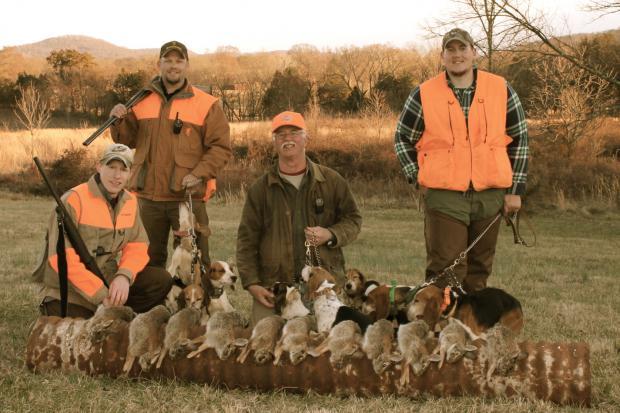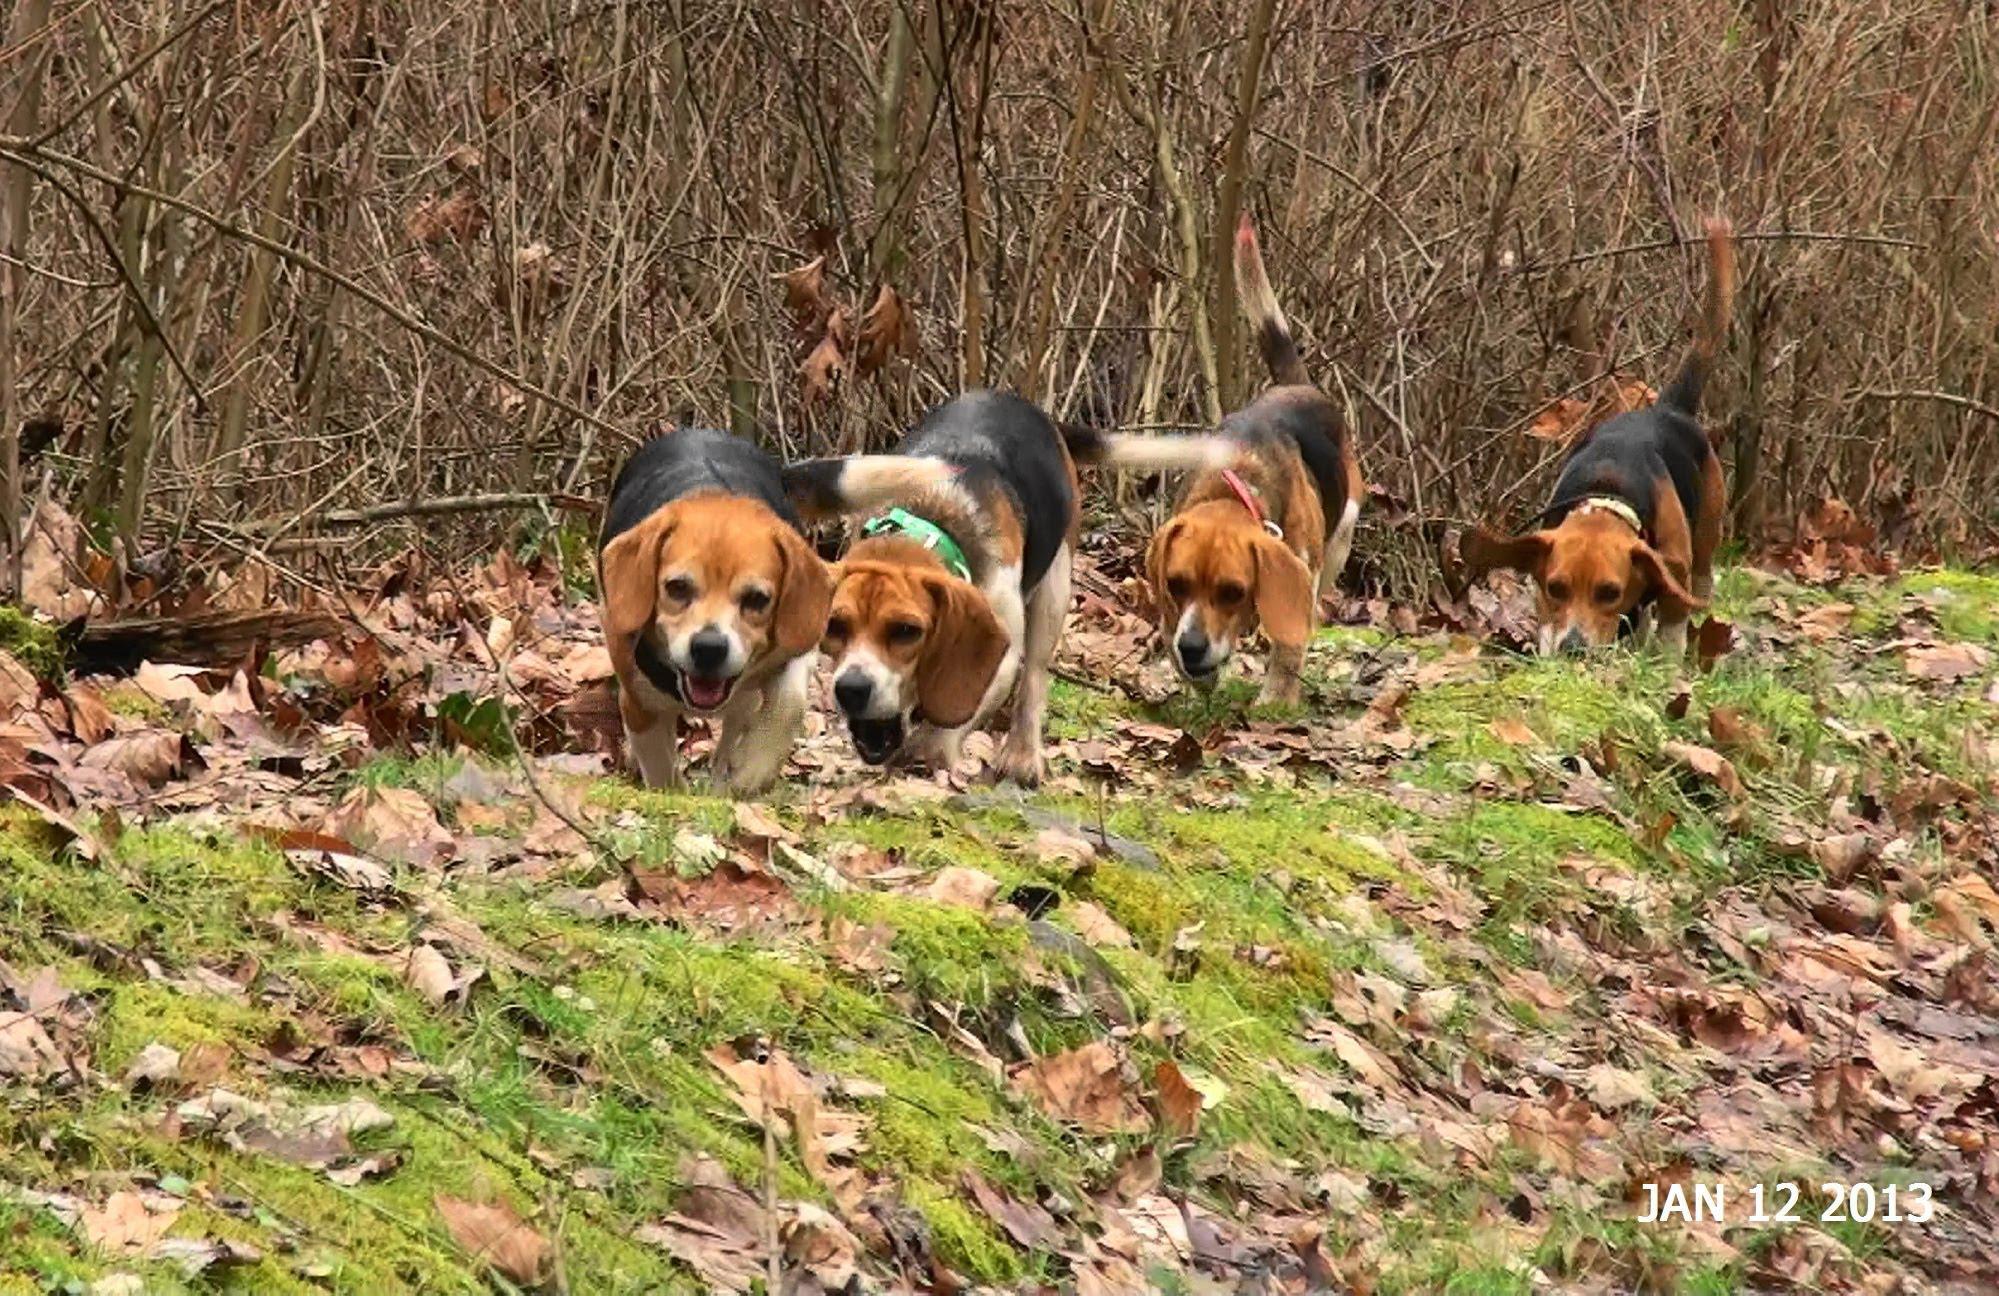The first image is the image on the left, the second image is the image on the right. Given the left and right images, does the statement "There are exactly two animals in the image on the left." hold true? Answer yes or no. No. 